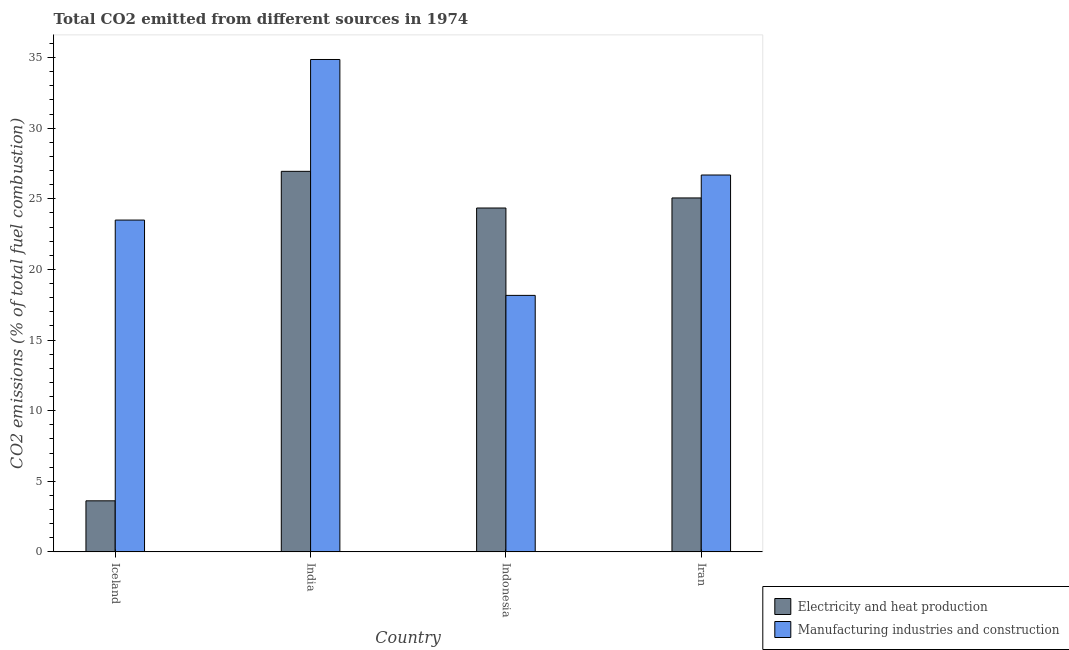Are the number of bars per tick equal to the number of legend labels?
Provide a succinct answer. Yes. Are the number of bars on each tick of the X-axis equal?
Provide a succinct answer. Yes. How many bars are there on the 1st tick from the left?
Provide a short and direct response. 2. What is the label of the 4th group of bars from the left?
Offer a terse response. Iran. In how many cases, is the number of bars for a given country not equal to the number of legend labels?
Make the answer very short. 0. What is the co2 emissions due to manufacturing industries in Iran?
Provide a short and direct response. 26.68. Across all countries, what is the maximum co2 emissions due to electricity and heat production?
Give a very brief answer. 26.94. Across all countries, what is the minimum co2 emissions due to electricity and heat production?
Offer a terse response. 3.61. In which country was the co2 emissions due to electricity and heat production maximum?
Your response must be concise. India. In which country was the co2 emissions due to electricity and heat production minimum?
Ensure brevity in your answer.  Iceland. What is the total co2 emissions due to electricity and heat production in the graph?
Provide a short and direct response. 79.97. What is the difference between the co2 emissions due to manufacturing industries in Indonesia and that in Iran?
Keep it short and to the point. -8.52. What is the difference between the co2 emissions due to electricity and heat production in Iran and the co2 emissions due to manufacturing industries in Iceland?
Your answer should be compact. 1.57. What is the average co2 emissions due to electricity and heat production per country?
Provide a succinct answer. 19.99. What is the difference between the co2 emissions due to electricity and heat production and co2 emissions due to manufacturing industries in Iran?
Your response must be concise. -1.62. What is the ratio of the co2 emissions due to manufacturing industries in Iceland to that in Iran?
Ensure brevity in your answer.  0.88. Is the difference between the co2 emissions due to manufacturing industries in Iceland and India greater than the difference between the co2 emissions due to electricity and heat production in Iceland and India?
Give a very brief answer. Yes. What is the difference between the highest and the second highest co2 emissions due to electricity and heat production?
Ensure brevity in your answer.  1.88. What is the difference between the highest and the lowest co2 emissions due to manufacturing industries?
Keep it short and to the point. 16.7. In how many countries, is the co2 emissions due to electricity and heat production greater than the average co2 emissions due to electricity and heat production taken over all countries?
Your answer should be very brief. 3. Is the sum of the co2 emissions due to electricity and heat production in India and Iran greater than the maximum co2 emissions due to manufacturing industries across all countries?
Provide a succinct answer. Yes. What does the 1st bar from the left in Indonesia represents?
Offer a terse response. Electricity and heat production. What does the 1st bar from the right in Indonesia represents?
Make the answer very short. Manufacturing industries and construction. Are all the bars in the graph horizontal?
Your answer should be compact. No. How many countries are there in the graph?
Give a very brief answer. 4. What is the difference between two consecutive major ticks on the Y-axis?
Your answer should be very brief. 5. Are the values on the major ticks of Y-axis written in scientific E-notation?
Your answer should be very brief. No. Does the graph contain grids?
Offer a very short reply. No. Where does the legend appear in the graph?
Your answer should be very brief. Bottom right. How many legend labels are there?
Offer a terse response. 2. How are the legend labels stacked?
Offer a terse response. Vertical. What is the title of the graph?
Make the answer very short. Total CO2 emitted from different sources in 1974. Does "Private credit bureau" appear as one of the legend labels in the graph?
Your answer should be very brief. No. What is the label or title of the X-axis?
Offer a terse response. Country. What is the label or title of the Y-axis?
Offer a very short reply. CO2 emissions (% of total fuel combustion). What is the CO2 emissions (% of total fuel combustion) in Electricity and heat production in Iceland?
Your answer should be very brief. 3.61. What is the CO2 emissions (% of total fuel combustion) of Manufacturing industries and construction in Iceland?
Keep it short and to the point. 23.49. What is the CO2 emissions (% of total fuel combustion) of Electricity and heat production in India?
Provide a short and direct response. 26.94. What is the CO2 emissions (% of total fuel combustion) of Manufacturing industries and construction in India?
Keep it short and to the point. 34.86. What is the CO2 emissions (% of total fuel combustion) in Electricity and heat production in Indonesia?
Offer a terse response. 24.35. What is the CO2 emissions (% of total fuel combustion) in Manufacturing industries and construction in Indonesia?
Offer a terse response. 18.16. What is the CO2 emissions (% of total fuel combustion) of Electricity and heat production in Iran?
Give a very brief answer. 25.06. What is the CO2 emissions (% of total fuel combustion) in Manufacturing industries and construction in Iran?
Your answer should be very brief. 26.68. Across all countries, what is the maximum CO2 emissions (% of total fuel combustion) in Electricity and heat production?
Offer a very short reply. 26.94. Across all countries, what is the maximum CO2 emissions (% of total fuel combustion) in Manufacturing industries and construction?
Your answer should be very brief. 34.86. Across all countries, what is the minimum CO2 emissions (% of total fuel combustion) of Electricity and heat production?
Provide a succinct answer. 3.61. Across all countries, what is the minimum CO2 emissions (% of total fuel combustion) in Manufacturing industries and construction?
Offer a terse response. 18.16. What is the total CO2 emissions (% of total fuel combustion) of Electricity and heat production in the graph?
Keep it short and to the point. 79.97. What is the total CO2 emissions (% of total fuel combustion) of Manufacturing industries and construction in the graph?
Your answer should be very brief. 103.2. What is the difference between the CO2 emissions (% of total fuel combustion) in Electricity and heat production in Iceland and that in India?
Give a very brief answer. -23.33. What is the difference between the CO2 emissions (% of total fuel combustion) in Manufacturing industries and construction in Iceland and that in India?
Make the answer very short. -11.37. What is the difference between the CO2 emissions (% of total fuel combustion) of Electricity and heat production in Iceland and that in Indonesia?
Provide a short and direct response. -20.73. What is the difference between the CO2 emissions (% of total fuel combustion) in Manufacturing industries and construction in Iceland and that in Indonesia?
Your answer should be compact. 5.33. What is the difference between the CO2 emissions (% of total fuel combustion) of Electricity and heat production in Iceland and that in Iran?
Keep it short and to the point. -21.45. What is the difference between the CO2 emissions (% of total fuel combustion) of Manufacturing industries and construction in Iceland and that in Iran?
Keep it short and to the point. -3.19. What is the difference between the CO2 emissions (% of total fuel combustion) of Electricity and heat production in India and that in Indonesia?
Provide a succinct answer. 2.6. What is the difference between the CO2 emissions (% of total fuel combustion) in Manufacturing industries and construction in India and that in Indonesia?
Make the answer very short. 16.7. What is the difference between the CO2 emissions (% of total fuel combustion) in Electricity and heat production in India and that in Iran?
Your answer should be compact. 1.88. What is the difference between the CO2 emissions (% of total fuel combustion) of Manufacturing industries and construction in India and that in Iran?
Ensure brevity in your answer.  8.18. What is the difference between the CO2 emissions (% of total fuel combustion) in Electricity and heat production in Indonesia and that in Iran?
Your answer should be very brief. -0.71. What is the difference between the CO2 emissions (% of total fuel combustion) in Manufacturing industries and construction in Indonesia and that in Iran?
Provide a short and direct response. -8.52. What is the difference between the CO2 emissions (% of total fuel combustion) of Electricity and heat production in Iceland and the CO2 emissions (% of total fuel combustion) of Manufacturing industries and construction in India?
Keep it short and to the point. -31.25. What is the difference between the CO2 emissions (% of total fuel combustion) of Electricity and heat production in Iceland and the CO2 emissions (% of total fuel combustion) of Manufacturing industries and construction in Indonesia?
Offer a very short reply. -14.55. What is the difference between the CO2 emissions (% of total fuel combustion) of Electricity and heat production in Iceland and the CO2 emissions (% of total fuel combustion) of Manufacturing industries and construction in Iran?
Your response must be concise. -23.07. What is the difference between the CO2 emissions (% of total fuel combustion) of Electricity and heat production in India and the CO2 emissions (% of total fuel combustion) of Manufacturing industries and construction in Indonesia?
Your answer should be very brief. 8.78. What is the difference between the CO2 emissions (% of total fuel combustion) of Electricity and heat production in India and the CO2 emissions (% of total fuel combustion) of Manufacturing industries and construction in Iran?
Provide a succinct answer. 0.26. What is the difference between the CO2 emissions (% of total fuel combustion) of Electricity and heat production in Indonesia and the CO2 emissions (% of total fuel combustion) of Manufacturing industries and construction in Iran?
Your answer should be compact. -2.34. What is the average CO2 emissions (% of total fuel combustion) of Electricity and heat production per country?
Provide a short and direct response. 19.99. What is the average CO2 emissions (% of total fuel combustion) in Manufacturing industries and construction per country?
Your response must be concise. 25.8. What is the difference between the CO2 emissions (% of total fuel combustion) in Electricity and heat production and CO2 emissions (% of total fuel combustion) in Manufacturing industries and construction in Iceland?
Provide a short and direct response. -19.88. What is the difference between the CO2 emissions (% of total fuel combustion) of Electricity and heat production and CO2 emissions (% of total fuel combustion) of Manufacturing industries and construction in India?
Ensure brevity in your answer.  -7.92. What is the difference between the CO2 emissions (% of total fuel combustion) of Electricity and heat production and CO2 emissions (% of total fuel combustion) of Manufacturing industries and construction in Indonesia?
Offer a very short reply. 6.19. What is the difference between the CO2 emissions (% of total fuel combustion) in Electricity and heat production and CO2 emissions (% of total fuel combustion) in Manufacturing industries and construction in Iran?
Provide a short and direct response. -1.62. What is the ratio of the CO2 emissions (% of total fuel combustion) of Electricity and heat production in Iceland to that in India?
Provide a succinct answer. 0.13. What is the ratio of the CO2 emissions (% of total fuel combustion) of Manufacturing industries and construction in Iceland to that in India?
Keep it short and to the point. 0.67. What is the ratio of the CO2 emissions (% of total fuel combustion) of Electricity and heat production in Iceland to that in Indonesia?
Keep it short and to the point. 0.15. What is the ratio of the CO2 emissions (% of total fuel combustion) of Manufacturing industries and construction in Iceland to that in Indonesia?
Provide a short and direct response. 1.29. What is the ratio of the CO2 emissions (% of total fuel combustion) in Electricity and heat production in Iceland to that in Iran?
Make the answer very short. 0.14. What is the ratio of the CO2 emissions (% of total fuel combustion) of Manufacturing industries and construction in Iceland to that in Iran?
Provide a succinct answer. 0.88. What is the ratio of the CO2 emissions (% of total fuel combustion) of Electricity and heat production in India to that in Indonesia?
Your response must be concise. 1.11. What is the ratio of the CO2 emissions (% of total fuel combustion) in Manufacturing industries and construction in India to that in Indonesia?
Your answer should be very brief. 1.92. What is the ratio of the CO2 emissions (% of total fuel combustion) of Electricity and heat production in India to that in Iran?
Keep it short and to the point. 1.08. What is the ratio of the CO2 emissions (% of total fuel combustion) in Manufacturing industries and construction in India to that in Iran?
Your answer should be very brief. 1.31. What is the ratio of the CO2 emissions (% of total fuel combustion) in Electricity and heat production in Indonesia to that in Iran?
Give a very brief answer. 0.97. What is the ratio of the CO2 emissions (% of total fuel combustion) in Manufacturing industries and construction in Indonesia to that in Iran?
Your answer should be very brief. 0.68. What is the difference between the highest and the second highest CO2 emissions (% of total fuel combustion) in Electricity and heat production?
Make the answer very short. 1.88. What is the difference between the highest and the second highest CO2 emissions (% of total fuel combustion) of Manufacturing industries and construction?
Your answer should be compact. 8.18. What is the difference between the highest and the lowest CO2 emissions (% of total fuel combustion) in Electricity and heat production?
Offer a very short reply. 23.33. What is the difference between the highest and the lowest CO2 emissions (% of total fuel combustion) of Manufacturing industries and construction?
Your response must be concise. 16.7. 